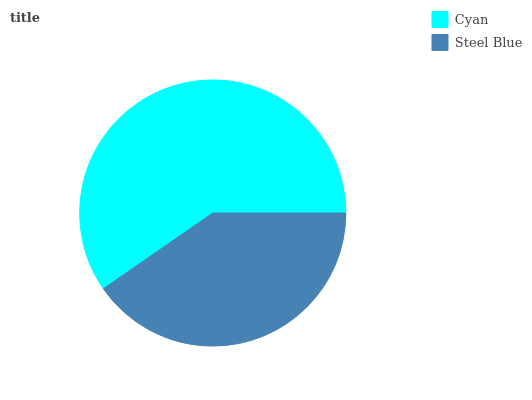Is Steel Blue the minimum?
Answer yes or no. Yes. Is Cyan the maximum?
Answer yes or no. Yes. Is Steel Blue the maximum?
Answer yes or no. No. Is Cyan greater than Steel Blue?
Answer yes or no. Yes. Is Steel Blue less than Cyan?
Answer yes or no. Yes. Is Steel Blue greater than Cyan?
Answer yes or no. No. Is Cyan less than Steel Blue?
Answer yes or no. No. Is Cyan the high median?
Answer yes or no. Yes. Is Steel Blue the low median?
Answer yes or no. Yes. Is Steel Blue the high median?
Answer yes or no. No. Is Cyan the low median?
Answer yes or no. No. 